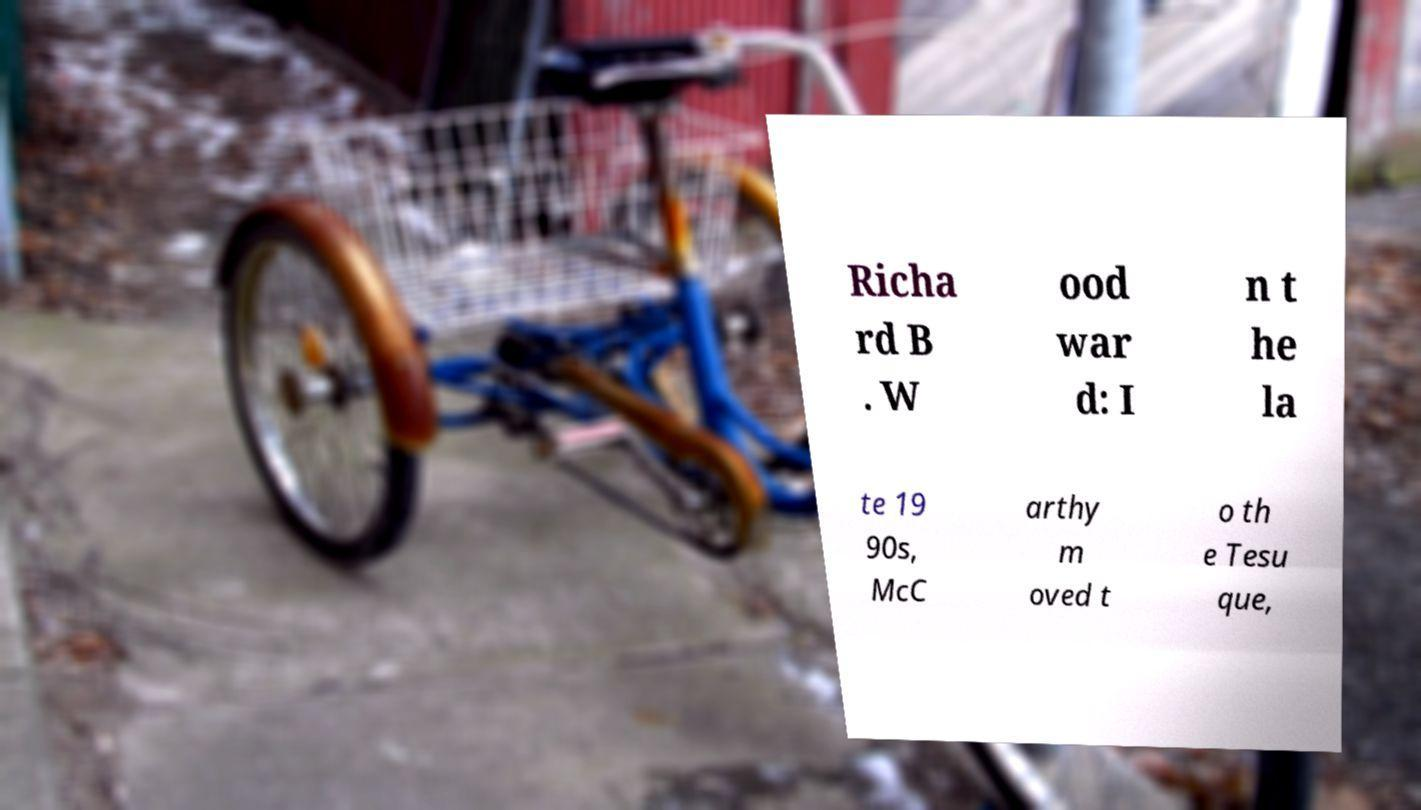Please identify and transcribe the text found in this image. Richa rd B . W ood war d: I n t he la te 19 90s, McC arthy m oved t o th e Tesu que, 